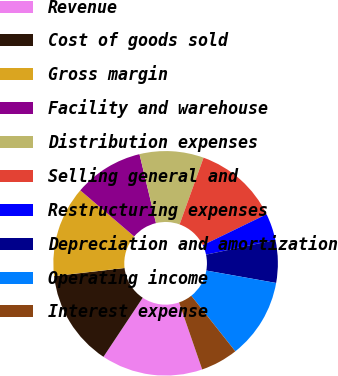Convert chart. <chart><loc_0><loc_0><loc_500><loc_500><pie_chart><fcel>Revenue<fcel>Cost of goods sold<fcel>Gross margin<fcel>Facility and warehouse<fcel>Distribution expenses<fcel>Selling general and<fcel>Restructuring expenses<fcel>Depreciation and amortization<fcel>Operating income<fcel>Interest expense<nl><fcel>14.62%<fcel>13.85%<fcel>13.08%<fcel>10.0%<fcel>9.23%<fcel>12.31%<fcel>3.85%<fcel>6.15%<fcel>11.54%<fcel>5.38%<nl></chart> 